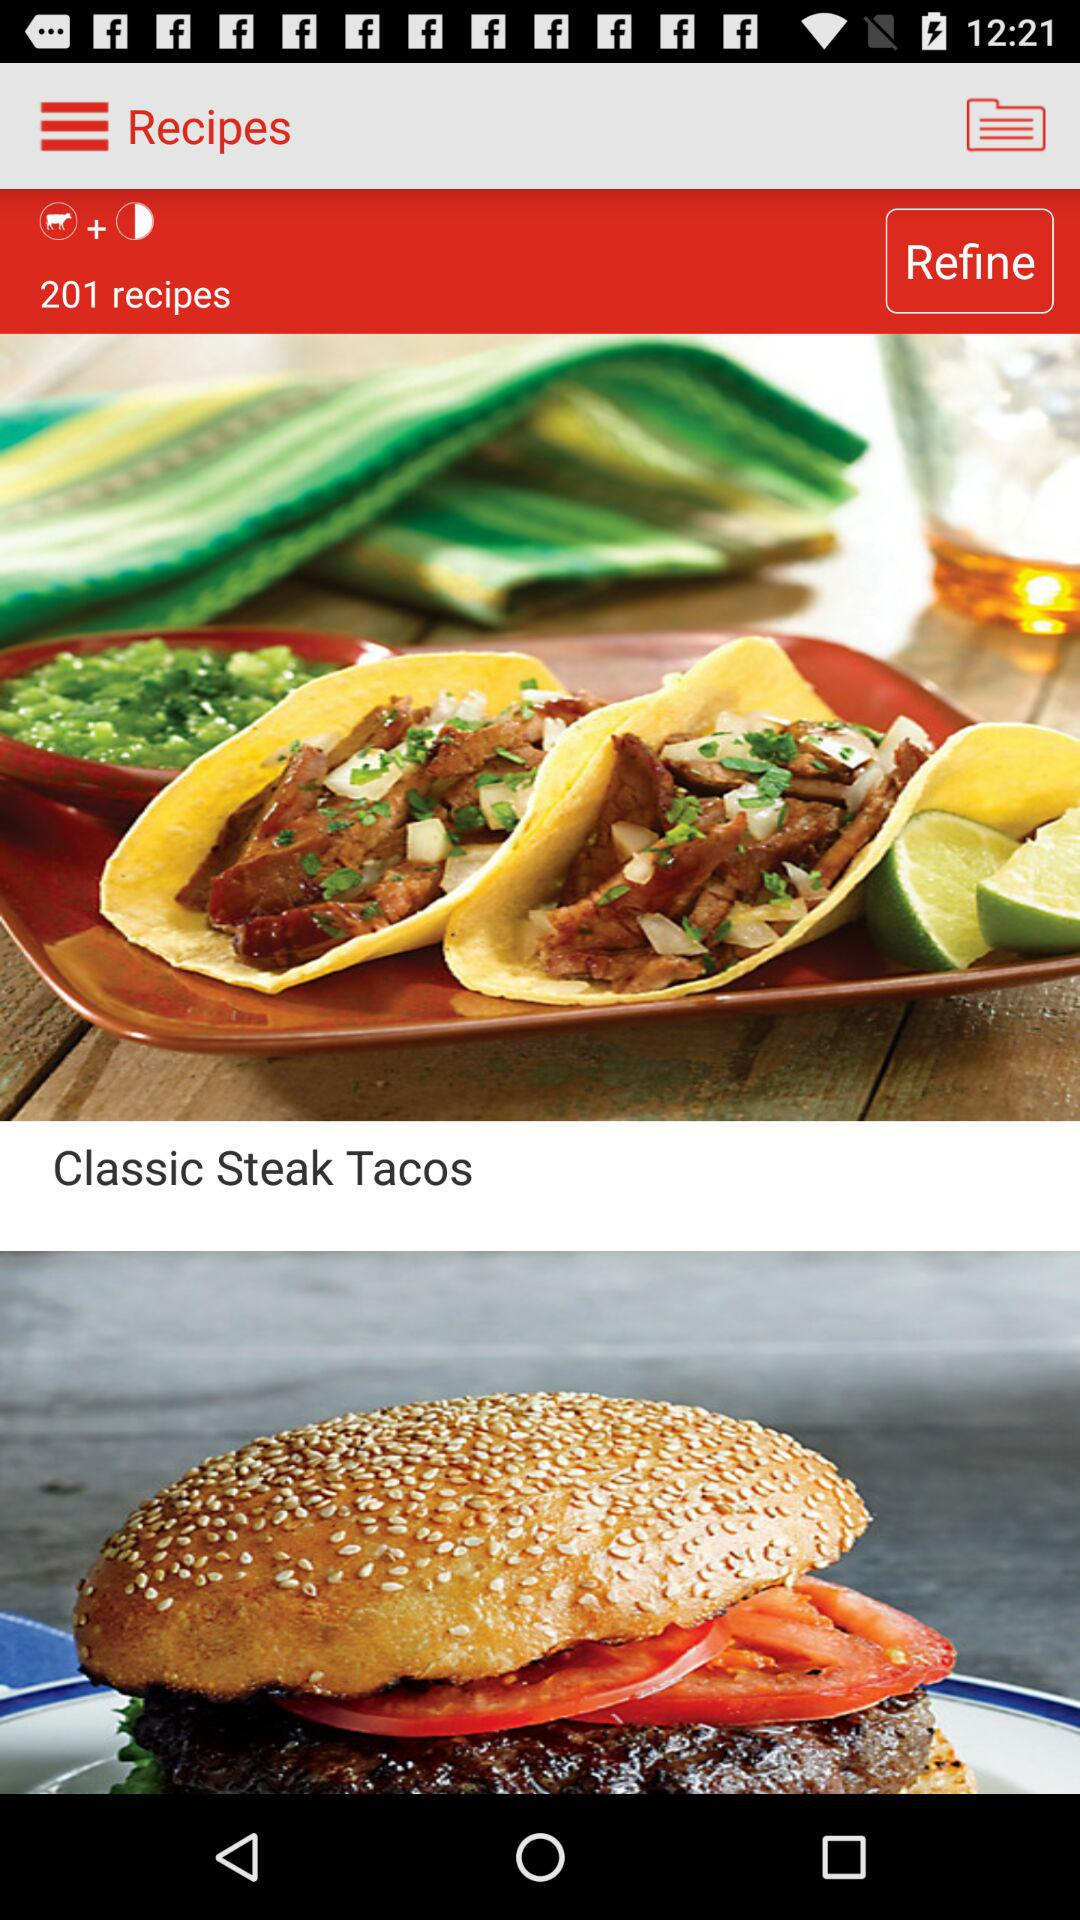How many recipes are there? There are 201 recipes. 